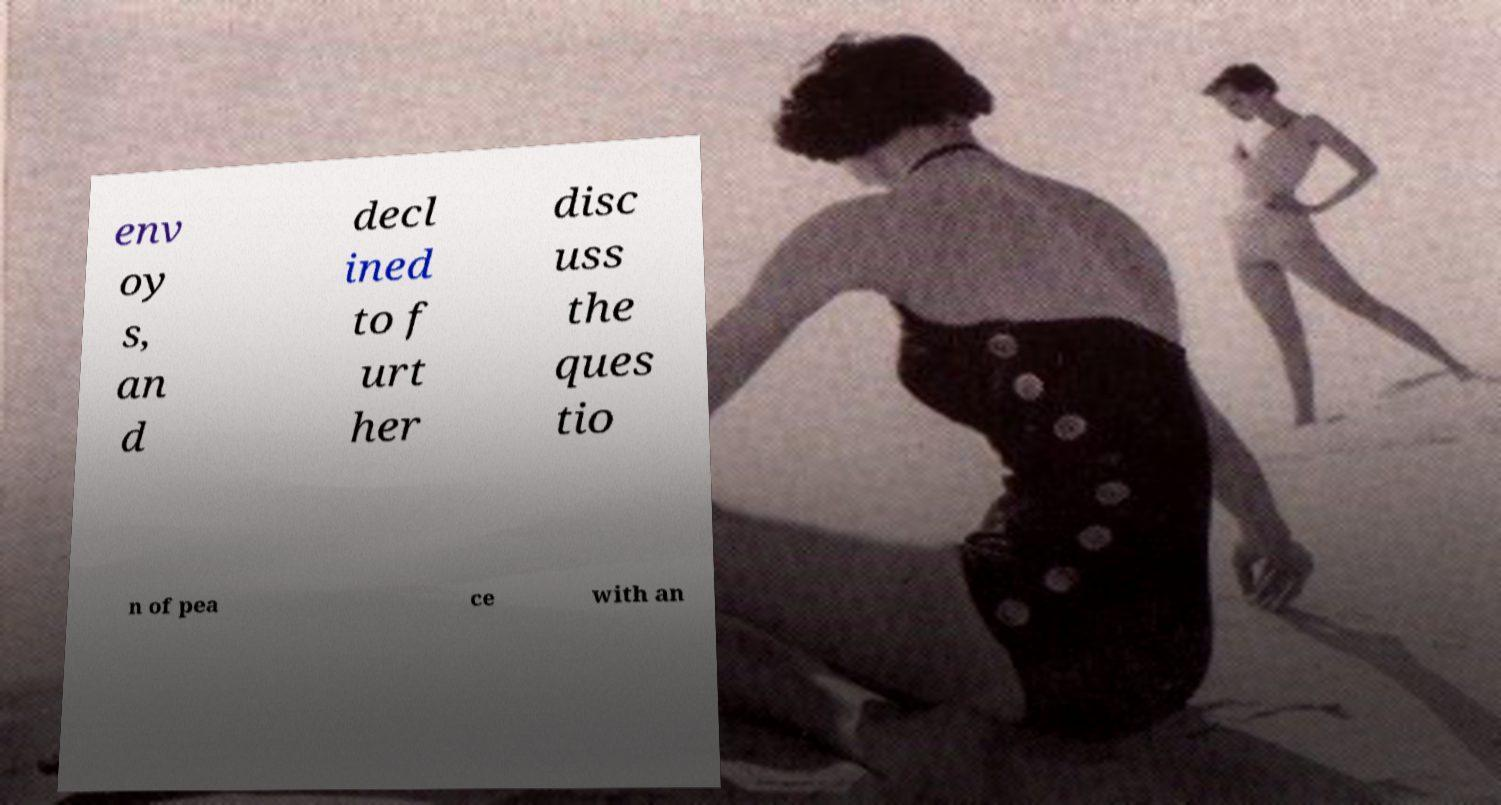There's text embedded in this image that I need extracted. Can you transcribe it verbatim? env oy s, an d decl ined to f urt her disc uss the ques tio n of pea ce with an 